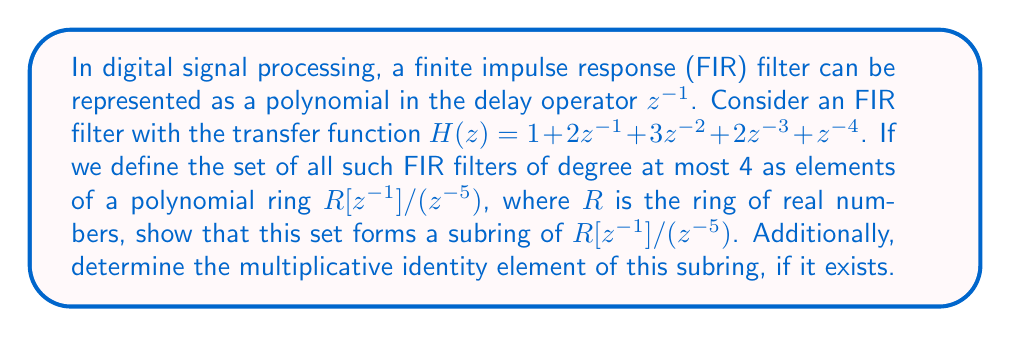Show me your answer to this math problem. To show that the set of FIR filters of degree at most 4 forms a subring of $R[z^{-1}]/(z^{-5})$, we need to prove that it is closed under addition and multiplication, and that it contains the additive identity.

1. Closure under addition:
   Let $f(z^{-1}) = a_0 + a_1z^{-1} + a_2z^{-2} + a_3z^{-3} + a_4z^{-4}$ and $g(z^{-1}) = b_0 + b_1z^{-1} + b_2z^{-2} + b_3z^{-3} + b_4z^{-4}$ be two FIR filters in the set.
   Their sum is:
   $$(f+g)(z^{-1}) = (a_0+b_0) + (a_1+b_1)z^{-1} + (a_2+b_2)z^{-2} + (a_3+b_3)z^{-3} + (a_4+b_4)z^{-4}$$
   This is also an FIR filter of degree at most 4, so the set is closed under addition.

2. Closure under multiplication:
   The product of $f(z^{-1})$ and $g(z^{-1})$ is:
   $$(f \cdot g)(z^{-1}) = c_0 + c_1z^{-1} + c_2z^{-2} + c_3z^{-3} + c_4z^{-4} + \text{higher order terms}$$
   where $c_i = \sum_{j=0}^i a_j b_{i-j}$ for $i = 0, 1, 2, 3, 4$.
   In the ring $R[z^{-1}]/(z^{-5})$, all terms of degree 5 and higher are equivalent to 0.
   Therefore, the product is also an FIR filter of degree at most 4, so the set is closed under multiplication.

3. Additive identity:
   The zero polynomial $0 + 0z^{-1} + 0z^{-2} + 0z^{-3} + 0z^{-4}$ is in the set and serves as the additive identity.

Thus, the set of FIR filters of degree at most 4 forms a subring of $R[z^{-1}]/(z^{-5})$.

To determine the multiplicative identity element, we need to find a polynomial $e(z^{-1})$ such that $e(z^{-1}) \cdot f(z^{-1}) = f(z^{-1})$ for all $f(z^{-1})$ in the subring.

The polynomial $e(z^{-1}) = 1 + 0z^{-1} + 0z^{-2} + 0z^{-3} + 0z^{-4}$ satisfies this condition:

$$(1 + 0z^{-1} + 0z^{-2} + 0z^{-3} + 0z^{-4})(a_0 + a_1z^{-1} + a_2z^{-2} + a_3z^{-3} + a_4z^{-4}) = a_0 + a_1z^{-1} + a_2z^{-2} + a_3z^{-3} + a_4z^{-4}$$

Therefore, the multiplicative identity element of this subring exists and is $1 + 0z^{-1} + 0z^{-2} + 0z^{-3} + 0z^{-4}$.
Answer: The set of FIR filters of degree at most 4 forms a subring of $R[z^{-1}]/(z^{-5})$. The multiplicative identity element of this subring is $1 + 0z^{-1} + 0z^{-2} + 0z^{-3} + 0z^{-4}$. 